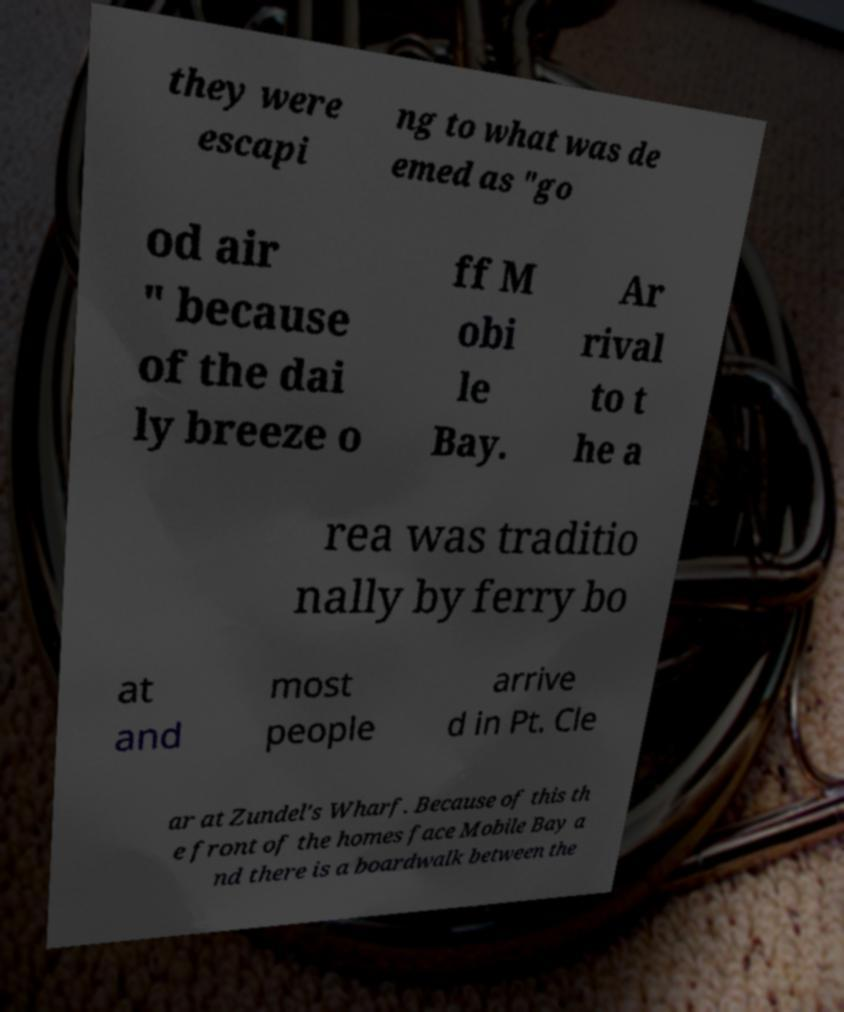Could you assist in decoding the text presented in this image and type it out clearly? they were escapi ng to what was de emed as "go od air " because of the dai ly breeze o ff M obi le Bay. Ar rival to t he a rea was traditio nally by ferry bo at and most people arrive d in Pt. Cle ar at Zundel's Wharf. Because of this th e front of the homes face Mobile Bay a nd there is a boardwalk between the 